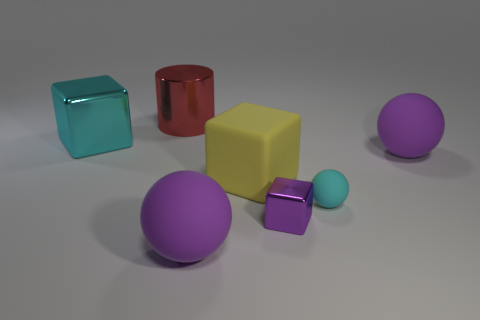How many blocks are red metal objects or large objects? Within the image, there are two objects that could be classified as either red metal or large objects. Specifically, there is one large yellow block and one red cylindrical object that appears to have a metallic sheen. 